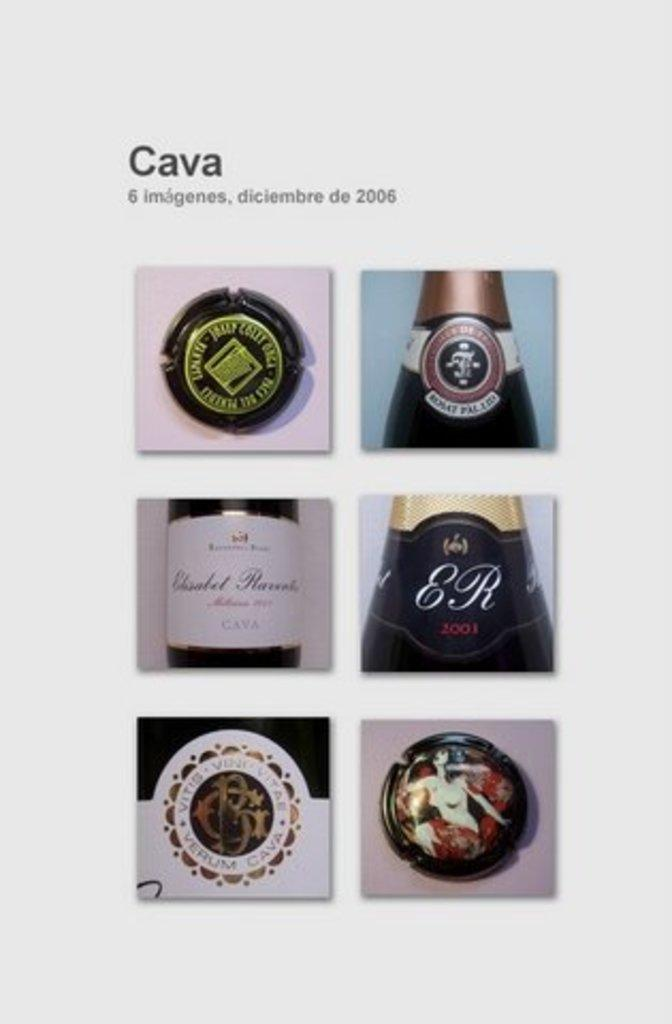<image>
Provide a brief description of the given image. Several bottles of wine are shown and one has "ER" on the label. 